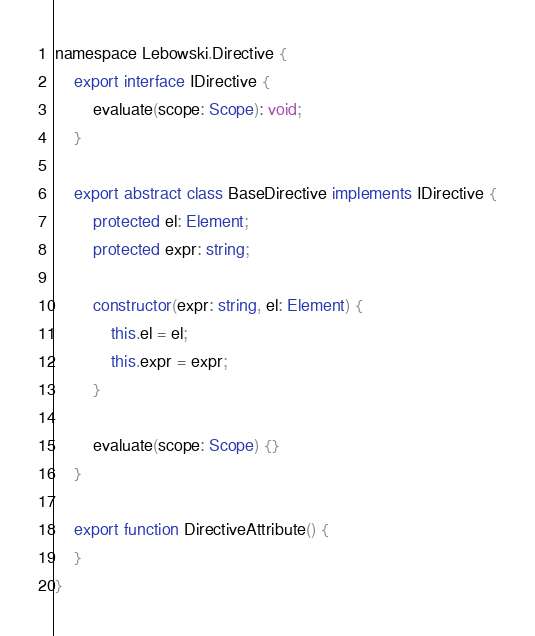Convert code to text. <code><loc_0><loc_0><loc_500><loc_500><_TypeScript_>namespace Lebowski.Directive {
    export interface IDirective {
        evaluate(scope: Scope): void;
    }

    export abstract class BaseDirective implements IDirective {
        protected el: Element;
        protected expr: string;

        constructor(expr: string, el: Element) {
            this.el = el;
            this.expr = expr;
        }

        evaluate(scope: Scope) {}
    }

    export function DirectiveAttribute() {
    }
}

</code> 